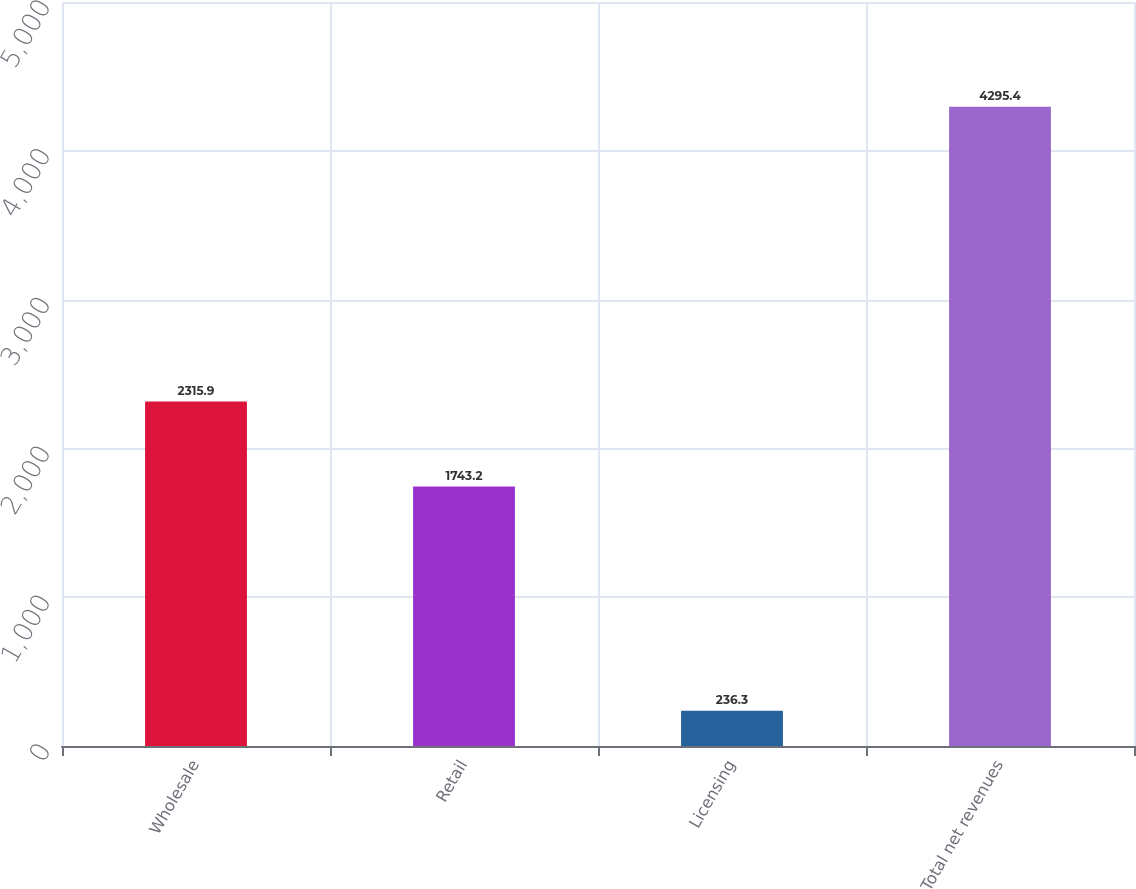<chart> <loc_0><loc_0><loc_500><loc_500><bar_chart><fcel>Wholesale<fcel>Retail<fcel>Licensing<fcel>Total net revenues<nl><fcel>2315.9<fcel>1743.2<fcel>236.3<fcel>4295.4<nl></chart> 